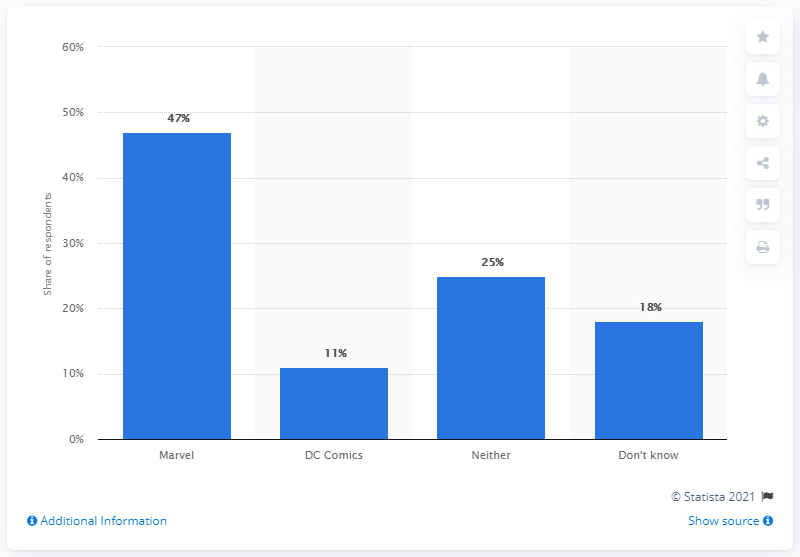Give some essential details in this illustration. The average of Marvel and DC comics fans in the US is 29. A significant percentage of people enjoy Marvel movies. 